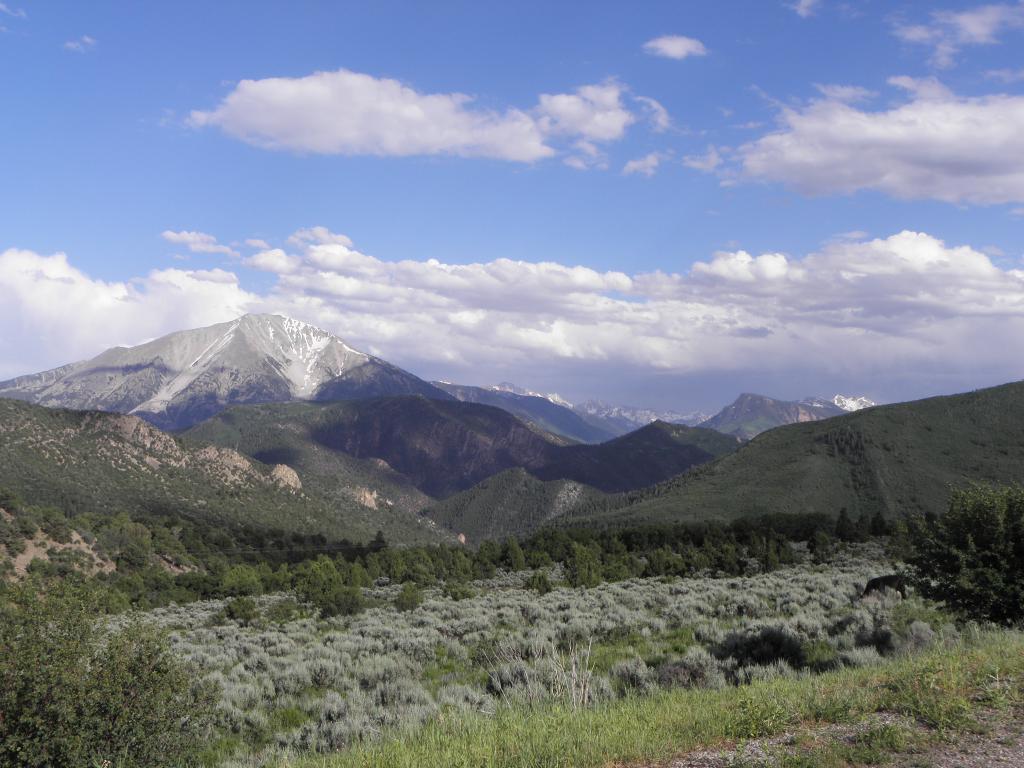Can you describe this image briefly? In this image we can see trees and plants. In the back there are hills. In the background there are mountains and there is sky with clouds. 